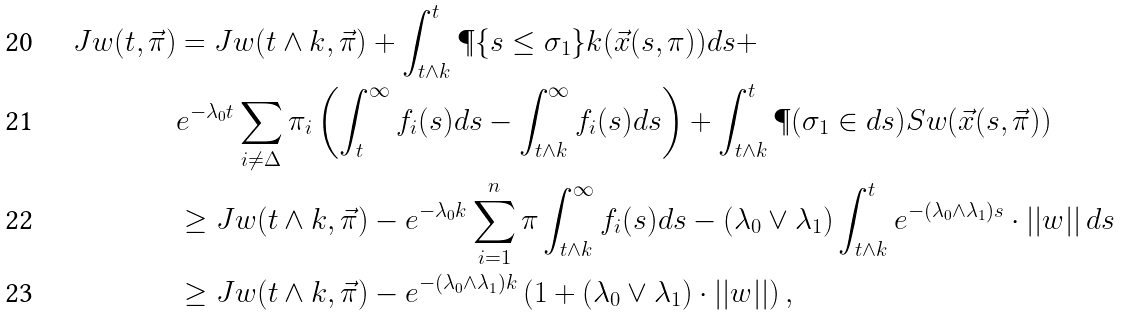Convert formula to latex. <formula><loc_0><loc_0><loc_500><loc_500>J w ( t , \vec { \pi } ) & = J w ( t \wedge k , \vec { \pi } ) + \int _ { t \wedge k } ^ { t } \P \{ s \leq \sigma _ { 1 } \} k ( \vec { x } ( s , \pi ) ) d s + \\ & e ^ { - \lambda _ { 0 } t } \sum _ { i \neq \Delta } \pi _ { i } \left ( \int _ { t } ^ { \infty } f _ { i } ( s ) d s - \int _ { t \wedge k } ^ { \infty } f _ { i } ( s ) d s \right ) + \int _ { t \wedge k } ^ { t } \P ( \sigma _ { 1 } \in d s ) S w ( \vec { x } ( s , \vec { \pi } ) ) \\ & \geq J w ( t \wedge k , \vec { \pi } ) - e ^ { - \lambda _ { 0 } k } \sum _ { i = 1 } ^ { n } \pi \int _ { t \wedge k } ^ { \infty } f _ { i } ( s ) d s - ( \lambda _ { 0 } \vee \lambda _ { 1 } ) \int _ { t \wedge k } ^ { t } e ^ { - ( \lambda _ { 0 } \wedge \lambda _ { 1 } ) s } \cdot | | w | | \, d s \\ & \geq J w ( t \wedge k , \vec { \pi } ) - e ^ { - ( \lambda _ { 0 } \wedge \lambda _ { 1 } ) k } \left ( 1 + ( \lambda _ { 0 } \vee \lambda _ { 1 } ) \cdot | | w | | \right ) ,</formula> 